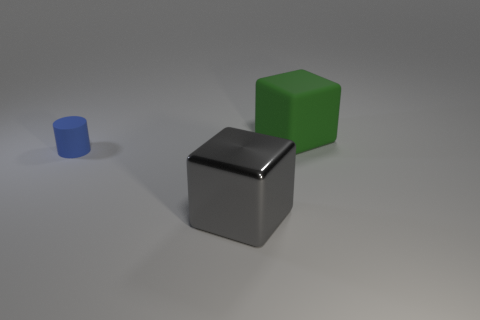Add 3 yellow cubes. How many objects exist? 6 Subtract all cylinders. How many objects are left? 2 Add 3 tiny red rubber balls. How many tiny red rubber balls exist? 3 Subtract 0 purple balls. How many objects are left? 3 Subtract all shiny objects. Subtract all gray blocks. How many objects are left? 1 Add 3 gray objects. How many gray objects are left? 4 